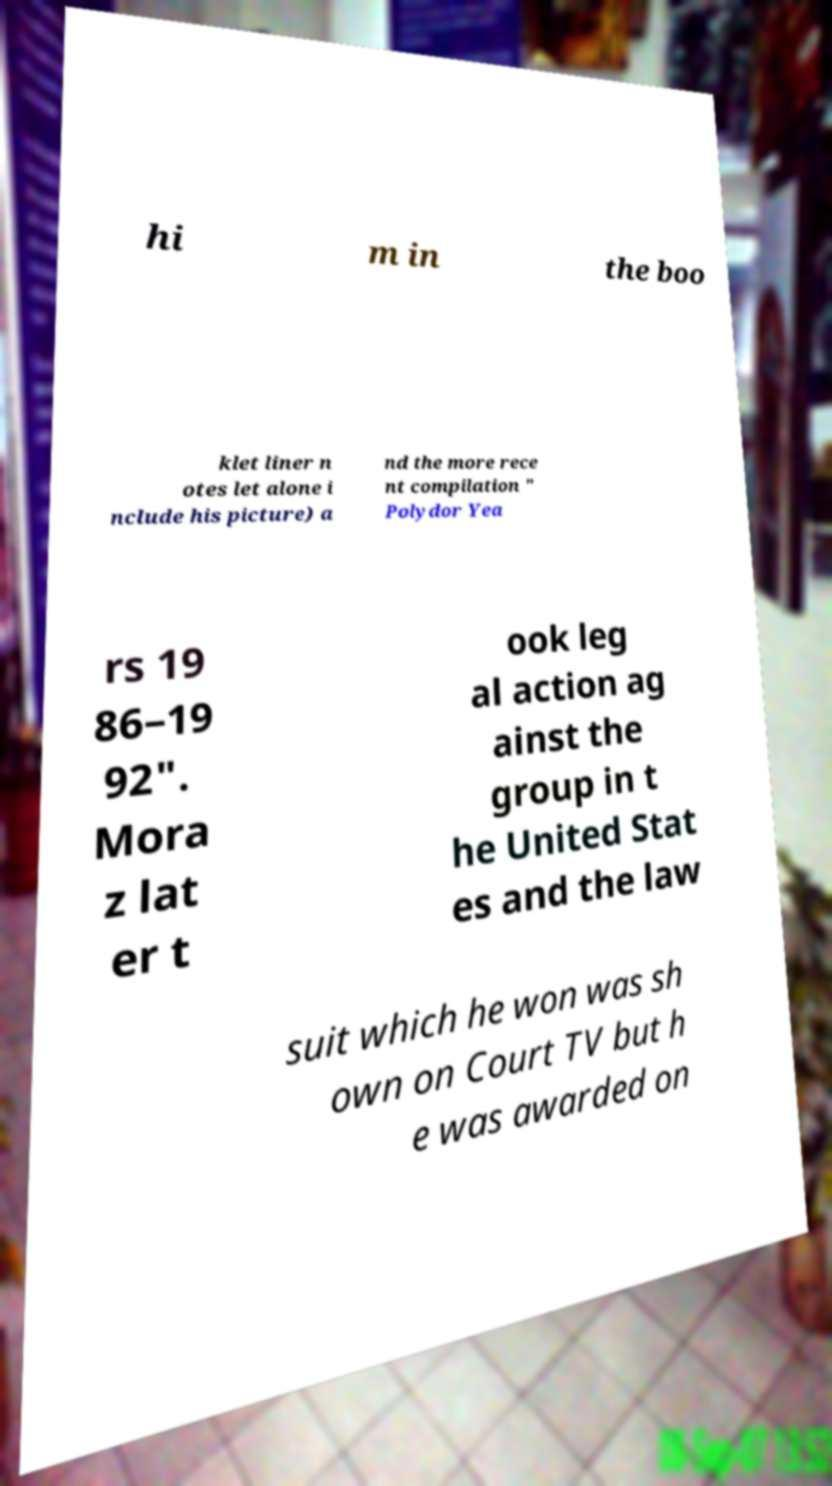For documentation purposes, I need the text within this image transcribed. Could you provide that? hi m in the boo klet liner n otes let alone i nclude his picture) a nd the more rece nt compilation " Polydor Yea rs 19 86–19 92". Mora z lat er t ook leg al action ag ainst the group in t he United Stat es and the law suit which he won was sh own on Court TV but h e was awarded on 